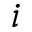<formula> <loc_0><loc_0><loc_500><loc_500>i</formula> 